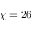<formula> <loc_0><loc_0><loc_500><loc_500>\chi = 2 6</formula> 